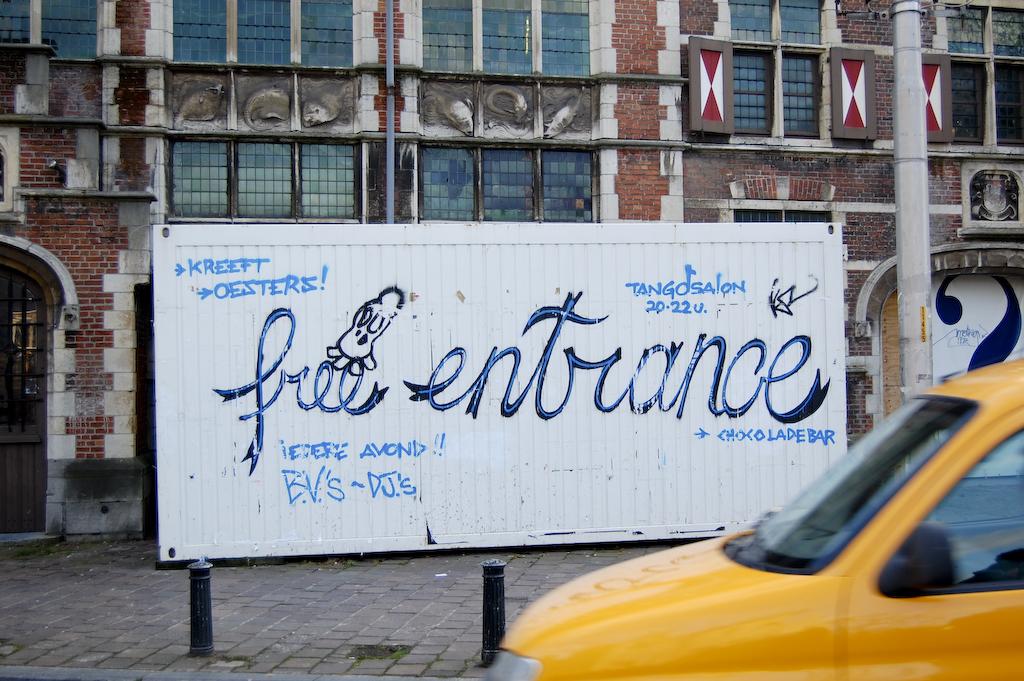What entrance is that?
Offer a very short reply. Free. What type of bar is on the sign?
Your response must be concise. Chocolade. 